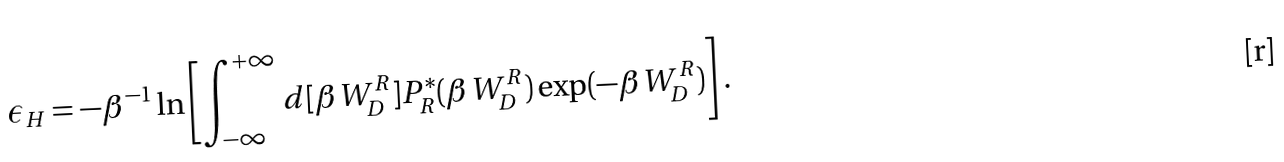Convert formula to latex. <formula><loc_0><loc_0><loc_500><loc_500>\epsilon _ { H } = - \beta ^ { - 1 } \ln \left [ \int _ { - \infty } ^ { + \infty } d [ \beta W _ { D } ^ { R } ] P _ { R } ^ { \ast } ( \beta W _ { D } ^ { R } ) \exp ( - \beta W _ { D } ^ { R } ) \right ] .</formula> 